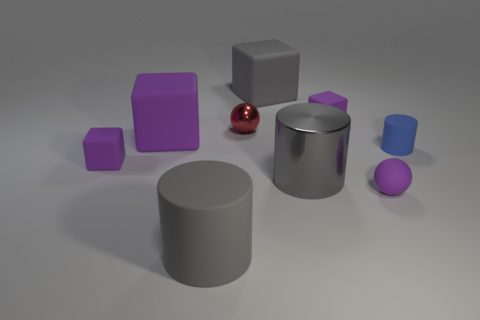Can you describe the shapes and their arrangement in the image? Certainly! The image shows a collection of geometric shapes arranged randomly on a flat surface. There are two purple cubes, a small red sphere, a medium-sized purple sphere, a large gray cylinder lying horizontally, and a smaller one standing vertically. The arrangement seems to lack a specific pattern, emphasizing a study of shape and color contrasts in a neutral setting. 